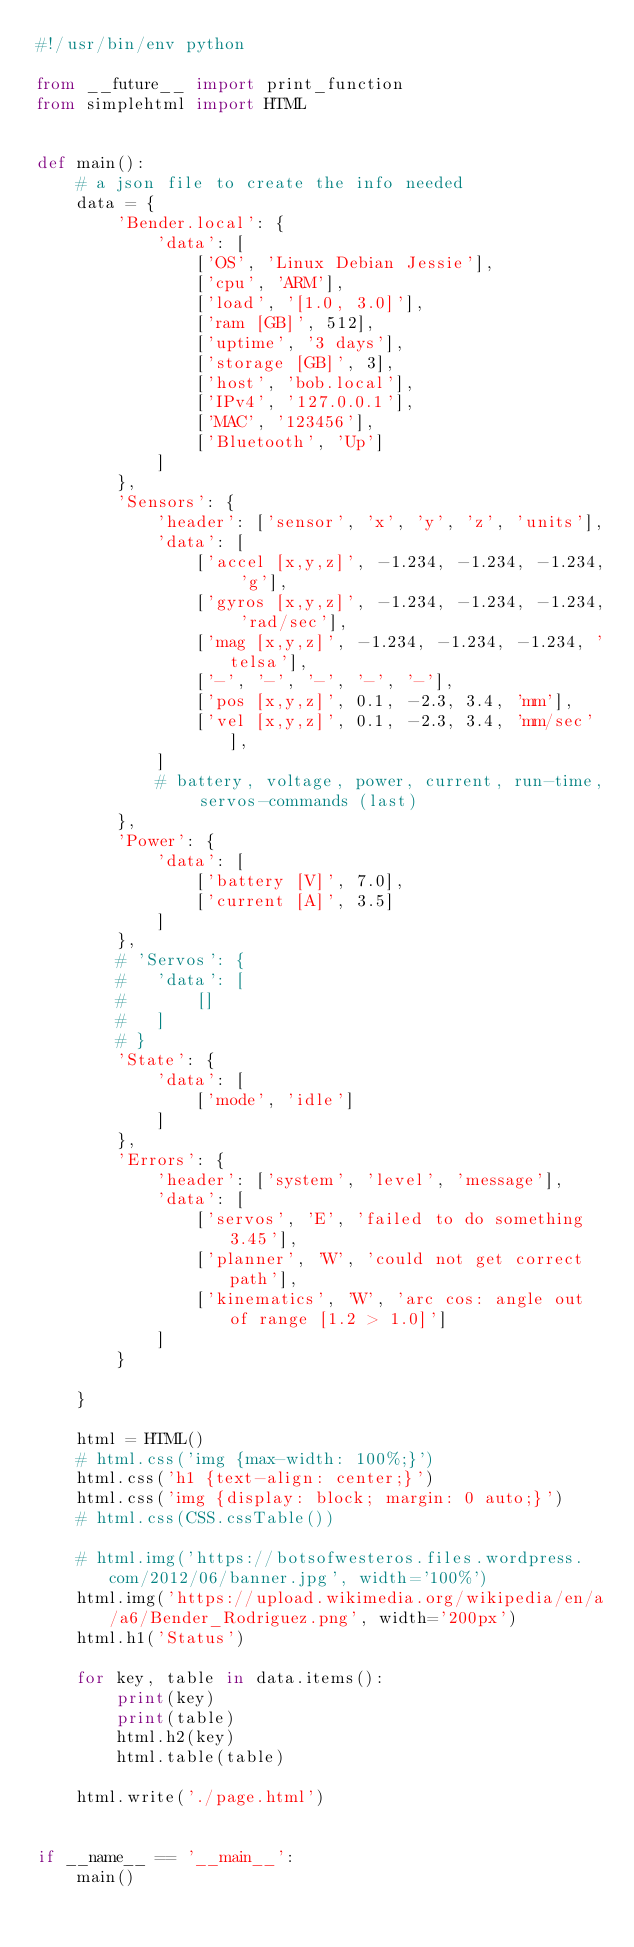<code> <loc_0><loc_0><loc_500><loc_500><_Python_>#!/usr/bin/env python

from __future__ import print_function
from simplehtml import HTML


def main():
	# a json file to create the info needed
	data = {
		'Bender.local': {
			'data': [
				['OS', 'Linux Debian Jessie'],
				['cpu', 'ARM'],
				['load', '[1.0, 3.0]'],
				['ram [GB]', 512],
				['uptime', '3 days'],
				['storage [GB]', 3],
				['host', 'bob.local'],
				['IPv4', '127.0.0.1'],
				['MAC', '123456'],
				['Bluetooth', 'Up']
			]
		},
		'Sensors': {
			'header': ['sensor', 'x', 'y', 'z', 'units'],
			'data': [
				['accel [x,y,z]', -1.234, -1.234, -1.234, 'g'],
				['gyros [x,y,z]', -1.234, -1.234, -1.234, 'rad/sec'],
				['mag [x,y,z]', -1.234, -1.234, -1.234, 'telsa'],
				['-', '-', '-', '-', '-'],
				['pos [x,y,z]', 0.1, -2.3, 3.4, 'mm'],
				['vel [x,y,z]', 0.1, -2.3, 3.4, 'mm/sec'],
			]
			# battery, voltage, power, current, run-time, servos-commands (last)
		},
		'Power': {
			'data': [
				['battery [V]', 7.0],
				['current [A]', 3.5]
			]
		},
		# 'Servos': {
		# 	'data': [
		# 		[]
		# 	]
		# }
		'State': {
			'data': [
				['mode', 'idle']
			]
		},
		'Errors': {
			'header': ['system', 'level', 'message'],
			'data': [
				['servos', 'E', 'failed to do something 3.45'],
				['planner', 'W', 'could not get correct path'],
				['kinematics', 'W', 'arc cos: angle out of range [1.2 > 1.0]']
			]
		}

	}

	html = HTML()
	# html.css('img {max-width: 100%;}')
	html.css('h1 {text-align: center;}')
	html.css('img {display: block; margin: 0 auto;}')
	# html.css(CSS.cssTable())

	# html.img('https://botsofwesteros.files.wordpress.com/2012/06/banner.jpg', width='100%')
	html.img('https://upload.wikimedia.org/wikipedia/en/a/a6/Bender_Rodriguez.png', width='200px')
	html.h1('Status')

	for key, table in data.items():
		print(key)
		print(table)
		html.h2(key)
		html.table(table)

	html.write('./page.html')


if __name__ == '__main__':
	main()
</code> 